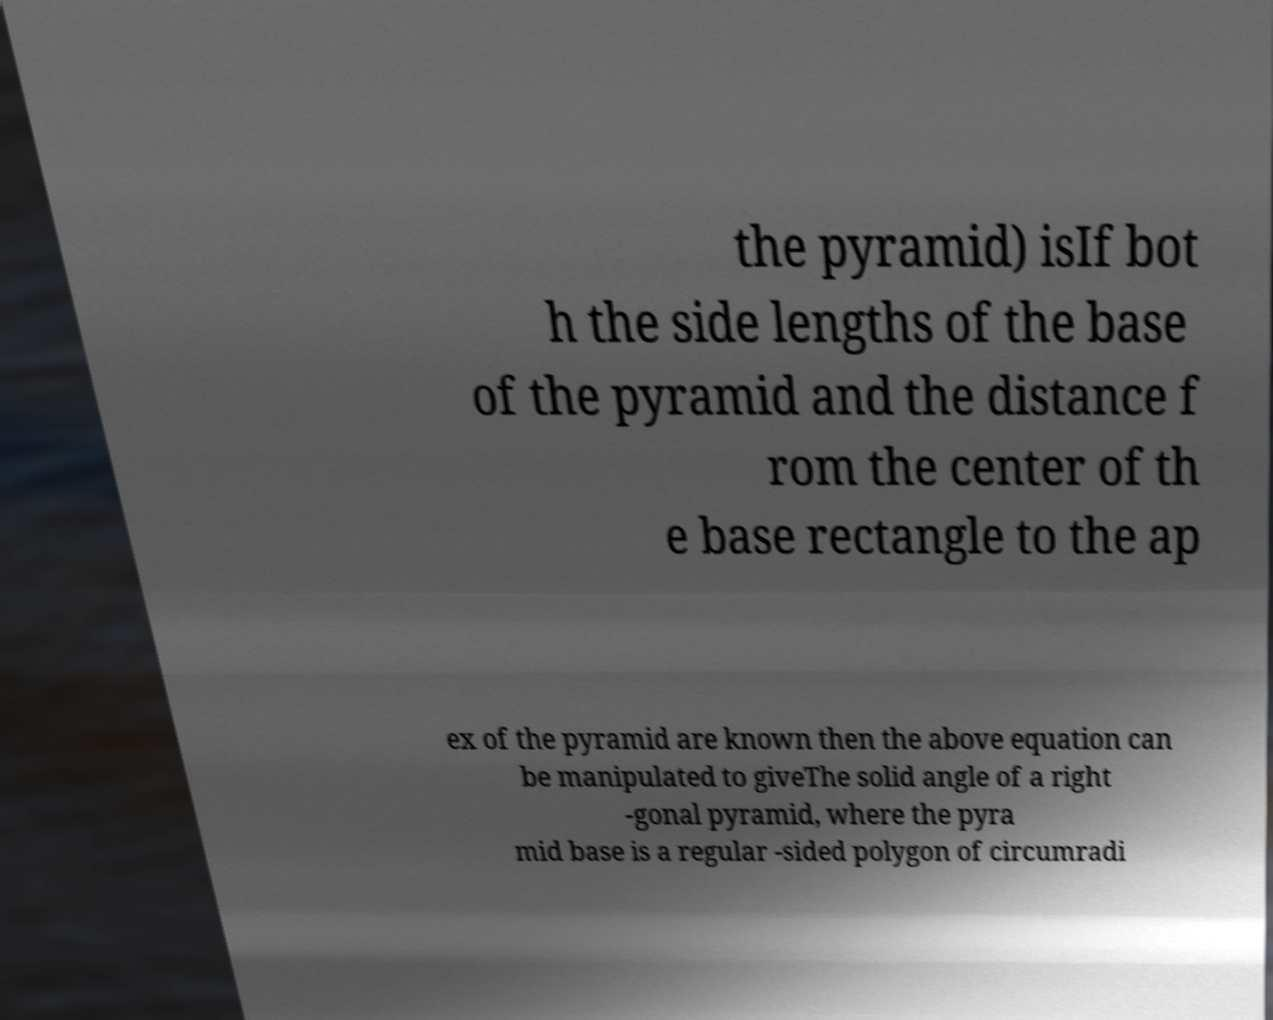Please identify and transcribe the text found in this image. the pyramid) isIf bot h the side lengths of the base of the pyramid and the distance f rom the center of th e base rectangle to the ap ex of the pyramid are known then the above equation can be manipulated to giveThe solid angle of a right -gonal pyramid, where the pyra mid base is a regular -sided polygon of circumradi 